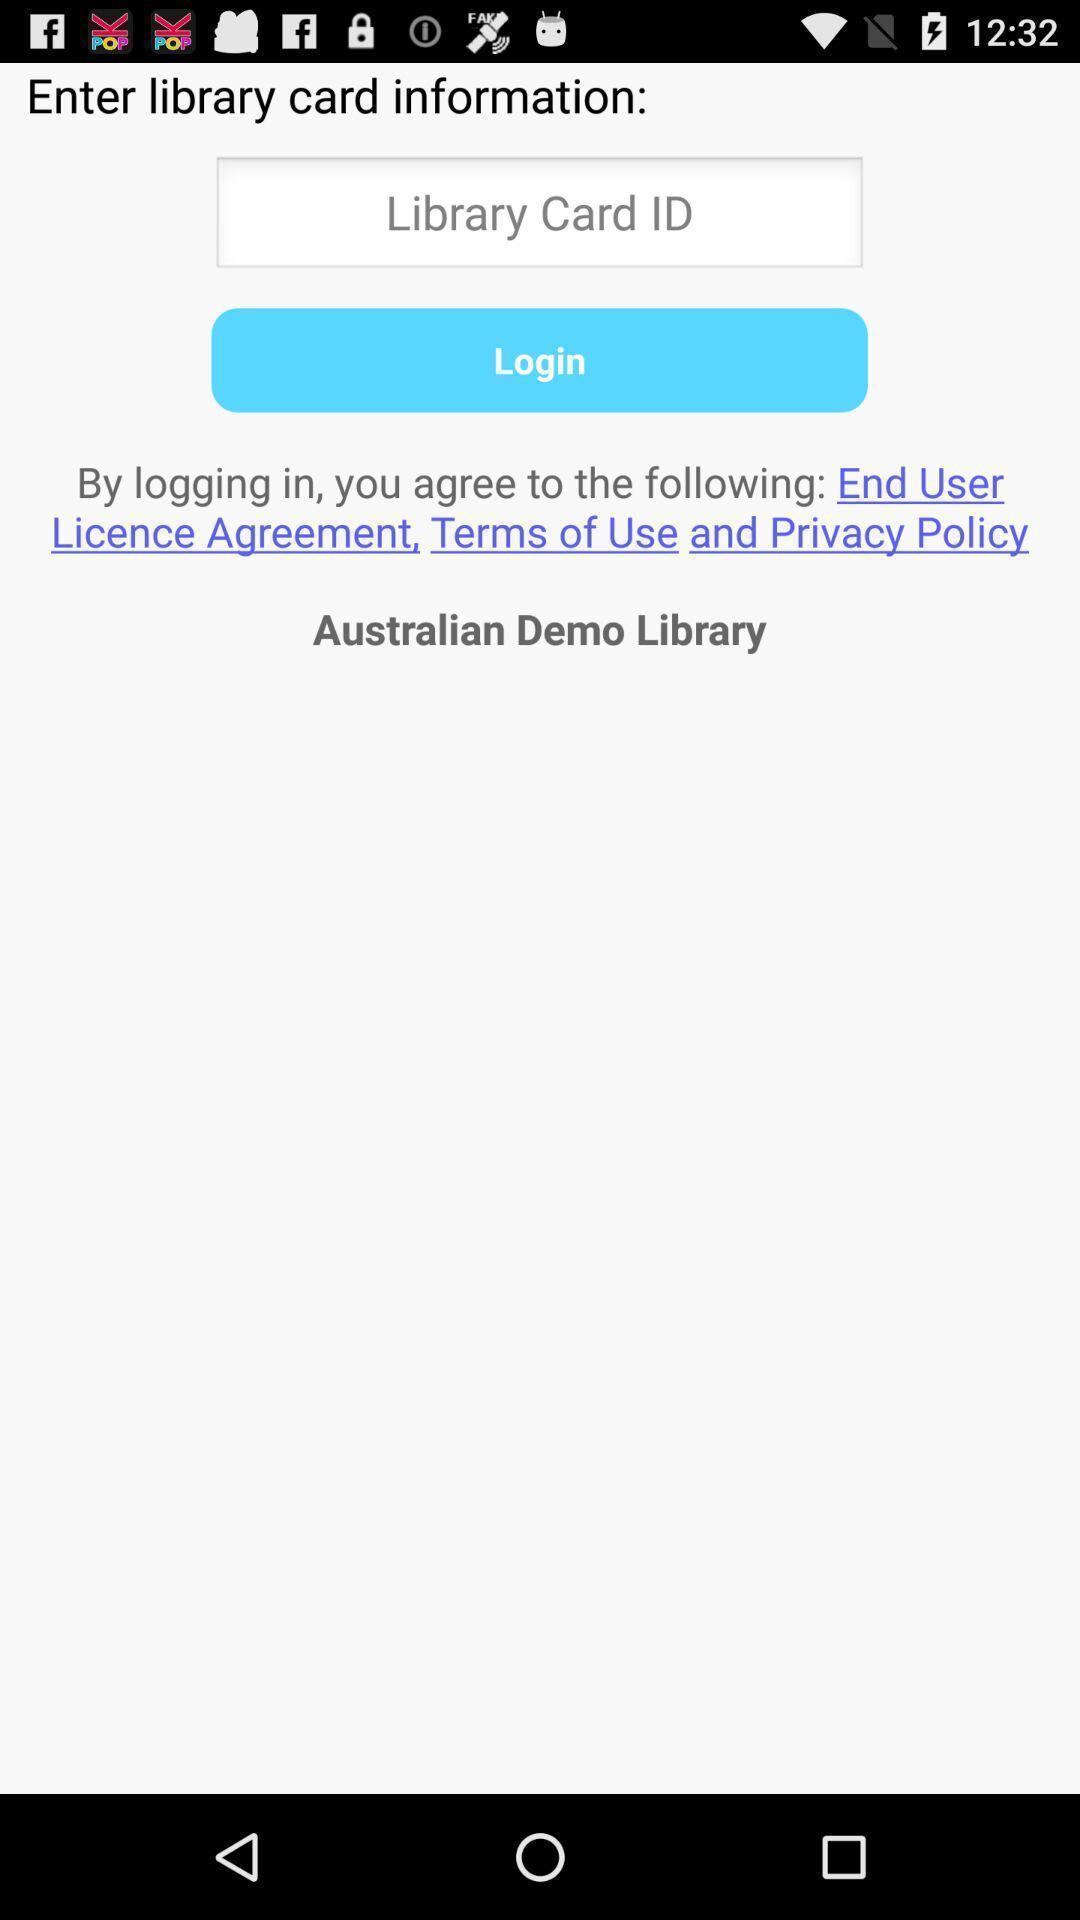Describe this image in words. Page showing login page. 